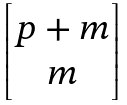<formula> <loc_0><loc_0><loc_500><loc_500>\begin{bmatrix} p + m \\ m \end{bmatrix}</formula> 